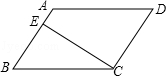Articulate your interpretation of the image. The image displays a parallelogram labeled as A, B, C, and D, with sides AB and CD parallel, showcasing the defining characteristic of a parallelogram. Another characteristic is the equal opposite angles, which could be inferred here. The line segment CE is drawn from vertex C to line AB and is perpendicular to AB, which suggests that it could be helpful in determining important properties such as the area of the parallelogram. Additionally, the angles at which sides meet and the relationships they reflect on property symmetries such as equal lengths and angle bisectors might offer deeper geometrical insights. 